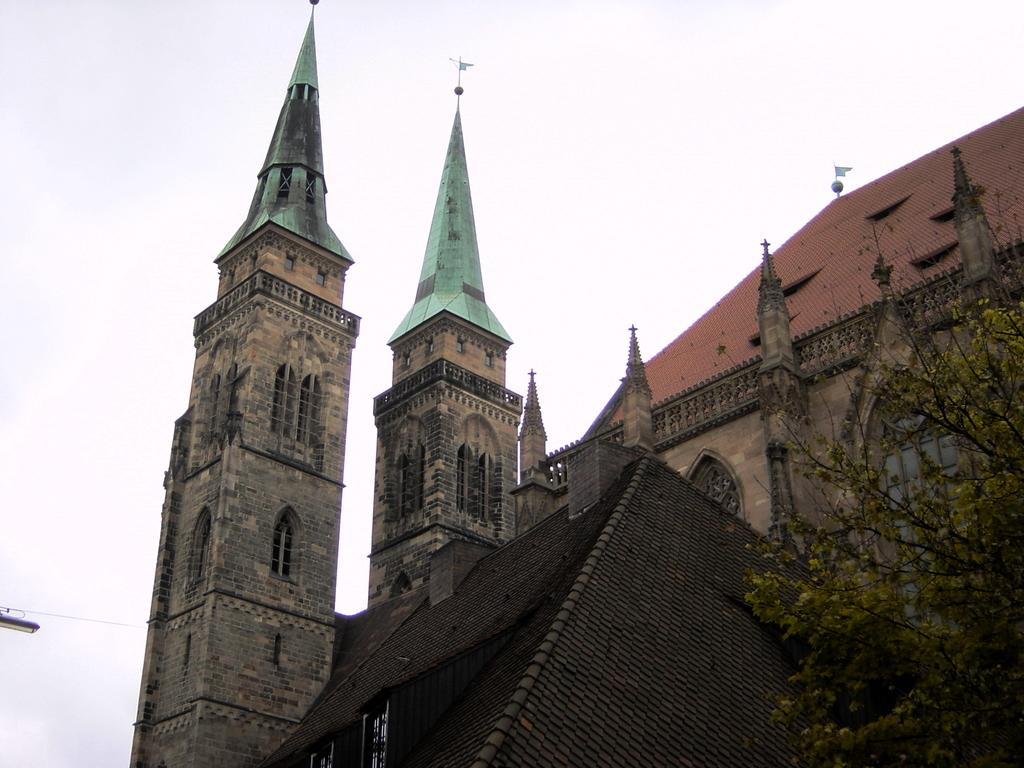What type of structure is present in the image? There is a building in the image. What feature can be observed on the building? The building has glass windows. What type of vegetation is visible in the image? There are trees in the image. What is the color of the sky in the image? The sky is white in color. Can you see any steam coming from the building in the image? There is no steam visible in the image. Is anyone wearing a scarf in the image? There is no information about people or clothing in the image, so it cannot be determined if anyone is wearing a scarf. 